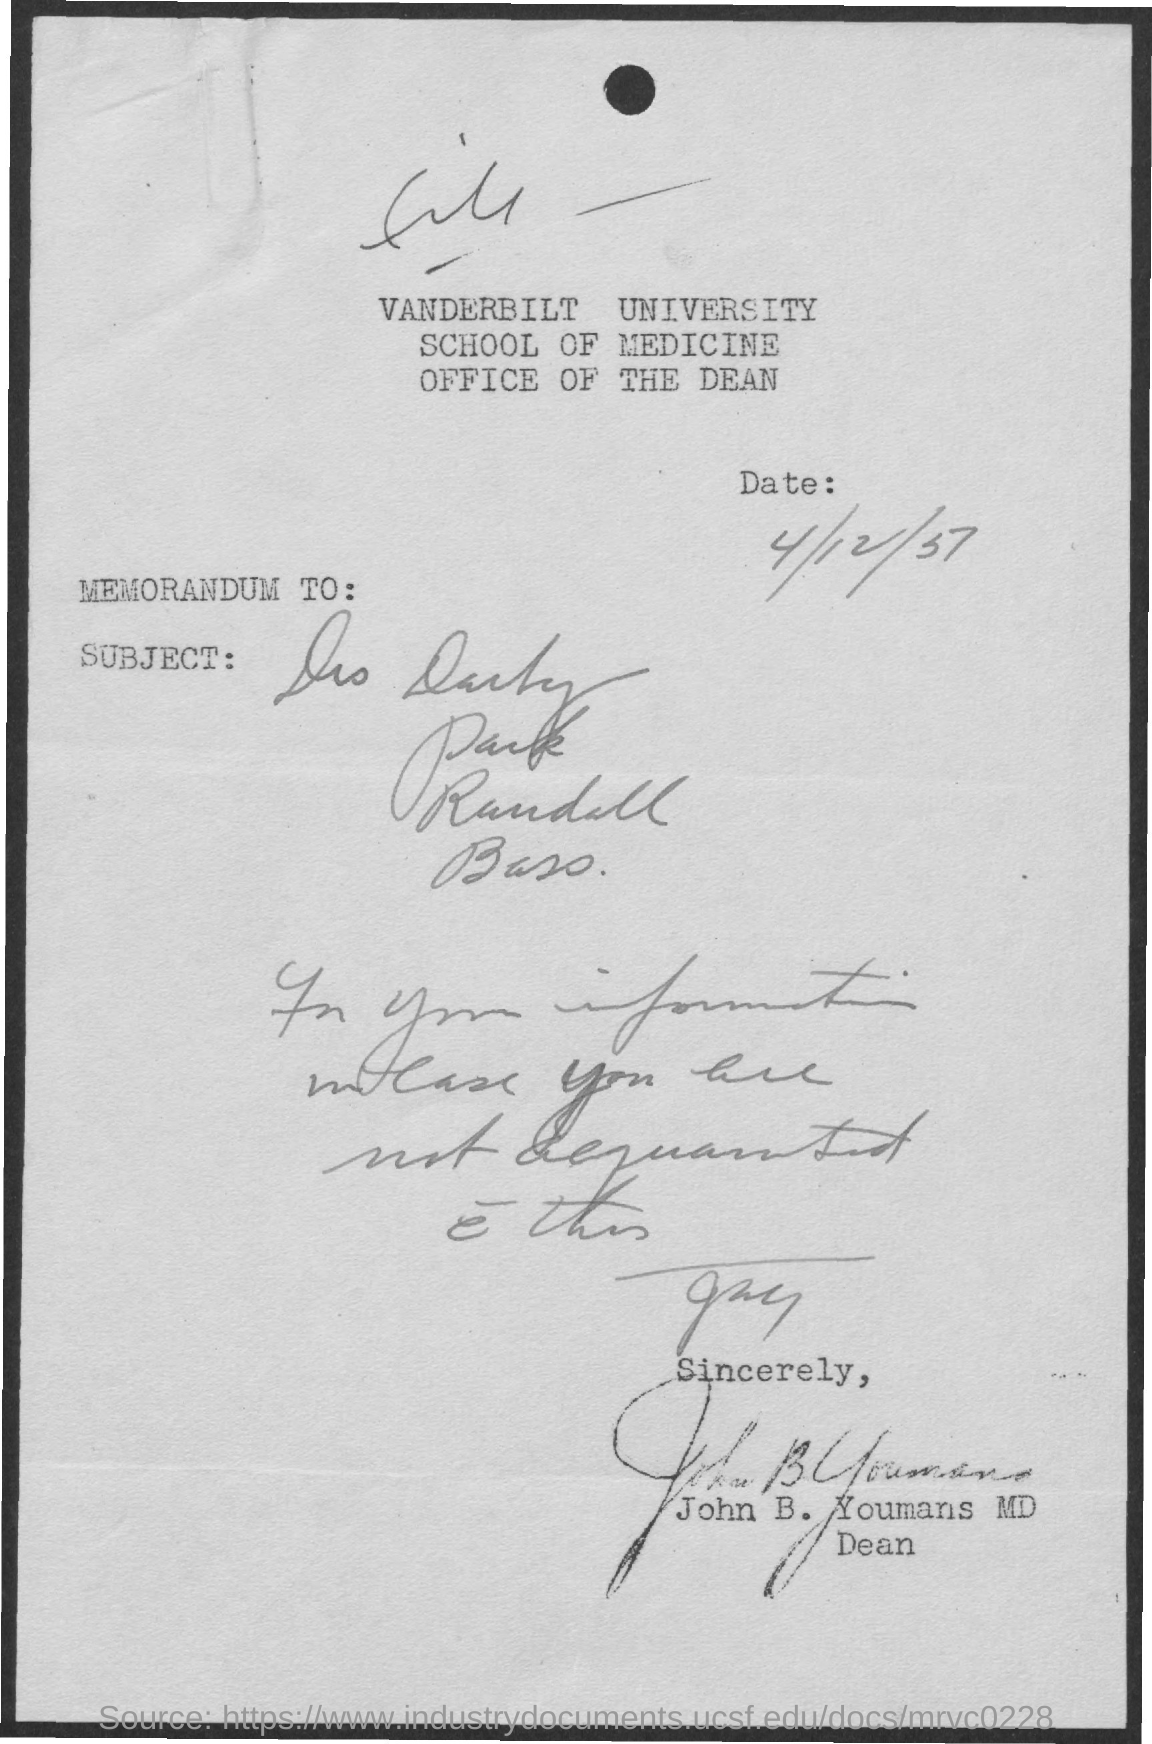What is the University Name ?
Give a very brief answer. VANDERBILT UNIVERSITY. 